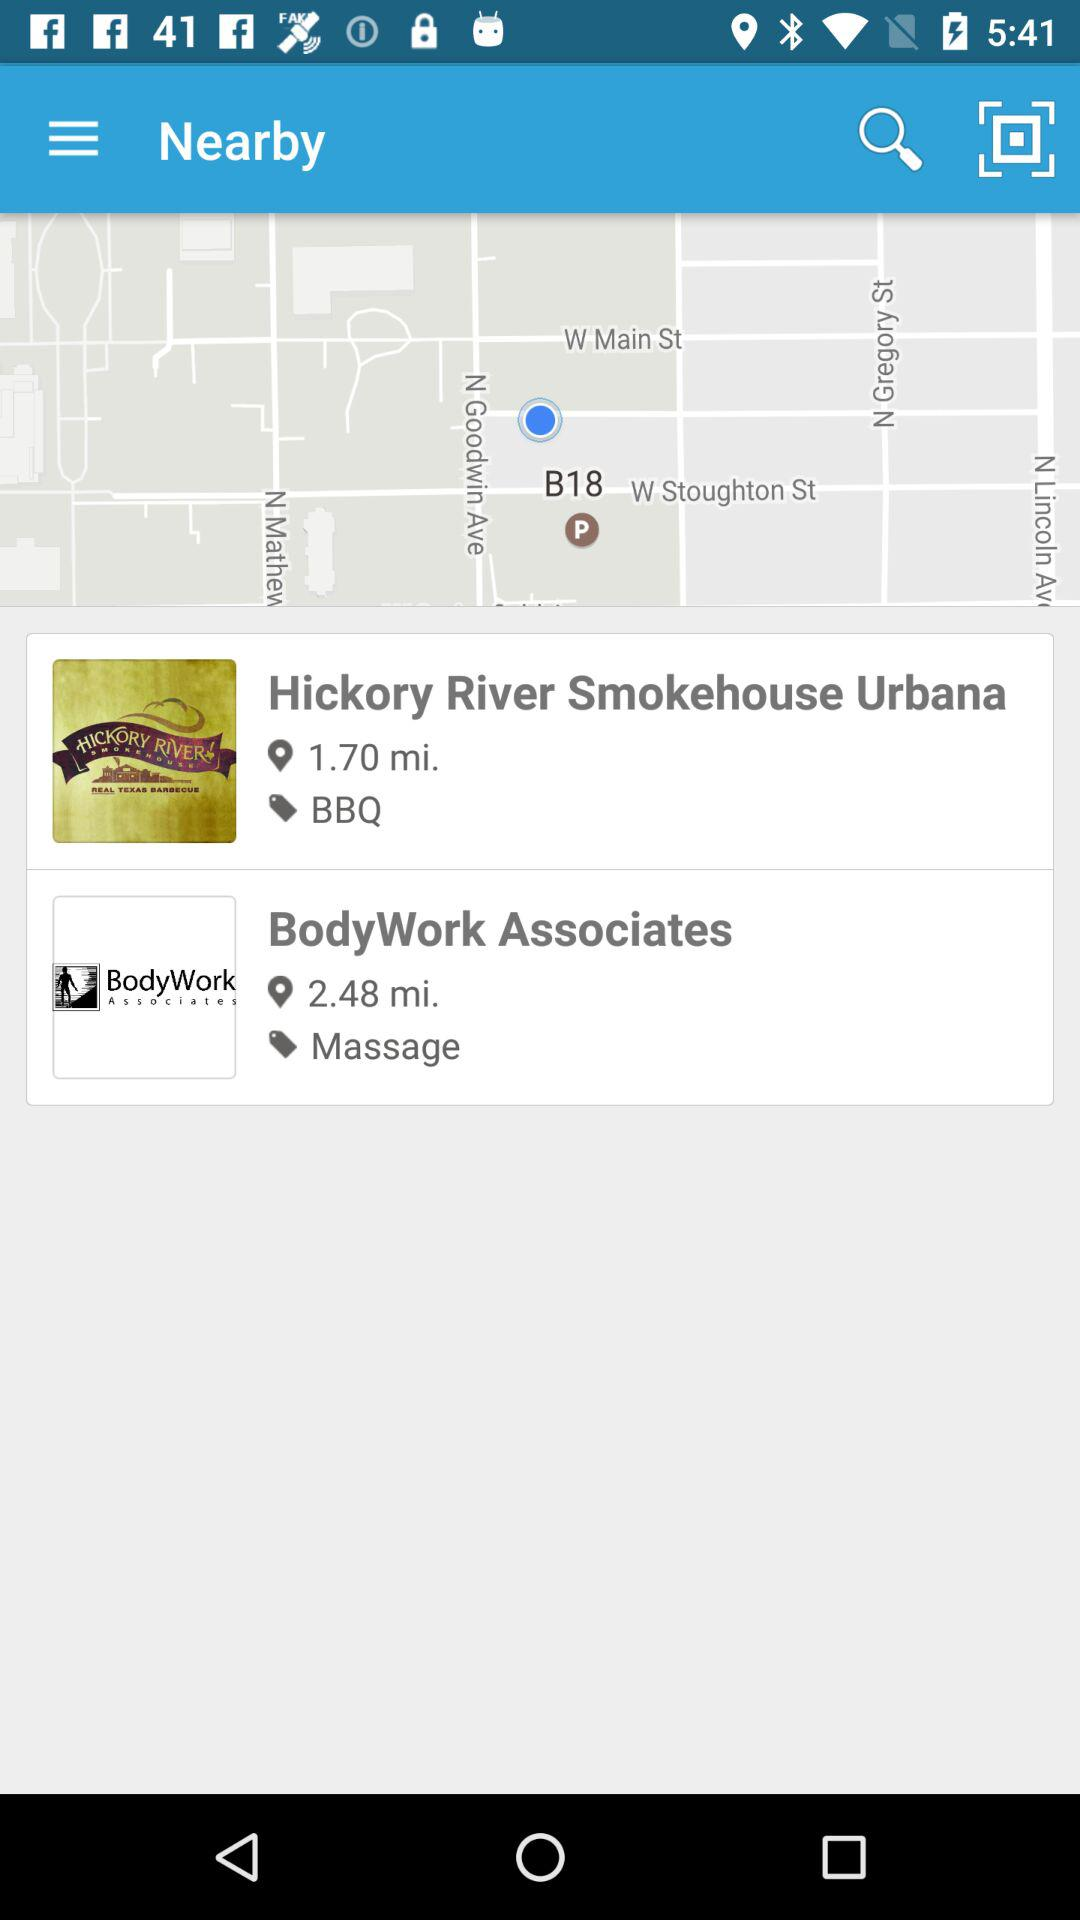How far is BodyWork Associates? BodyWork Associates is 2.48 miles away. 